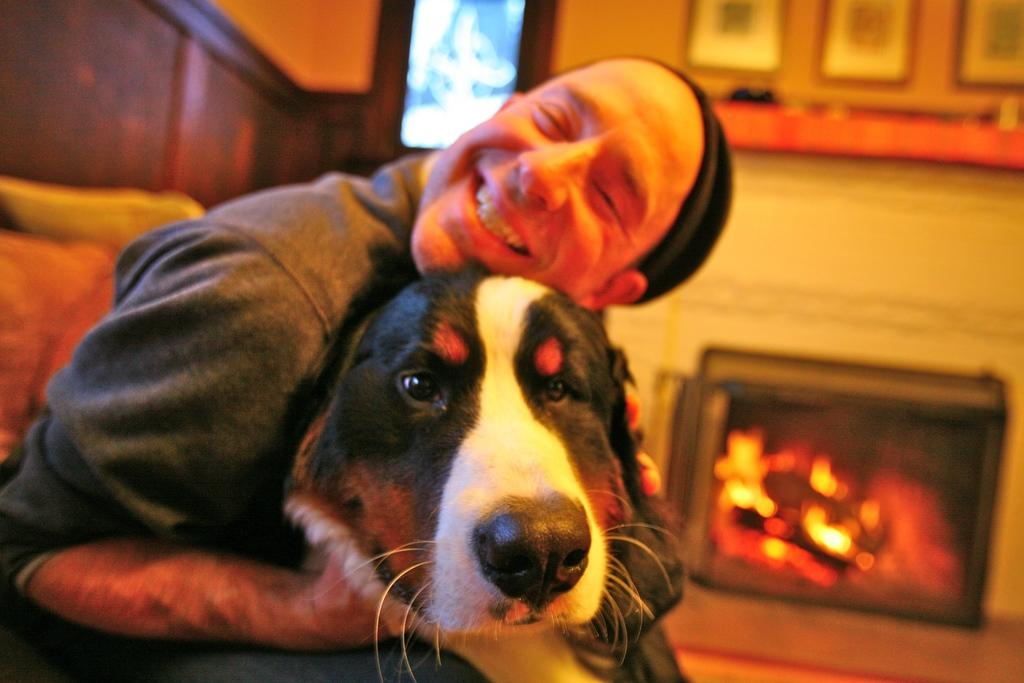Who or what is present in the image? There is a person and a dog in the image. What is the person doing in the image? The person is smiling in the image. What can be seen in the background of the image? There is a fireplace and a wall in the background of the image. What is attached to the wall in the background? Photos are attached to the wall in the background. What type of whip is being used by the person in the image? There is no whip present in the image; the person is simply smiling. What class is the person attending in the image? There is no indication of a class or educational setting in the image. 